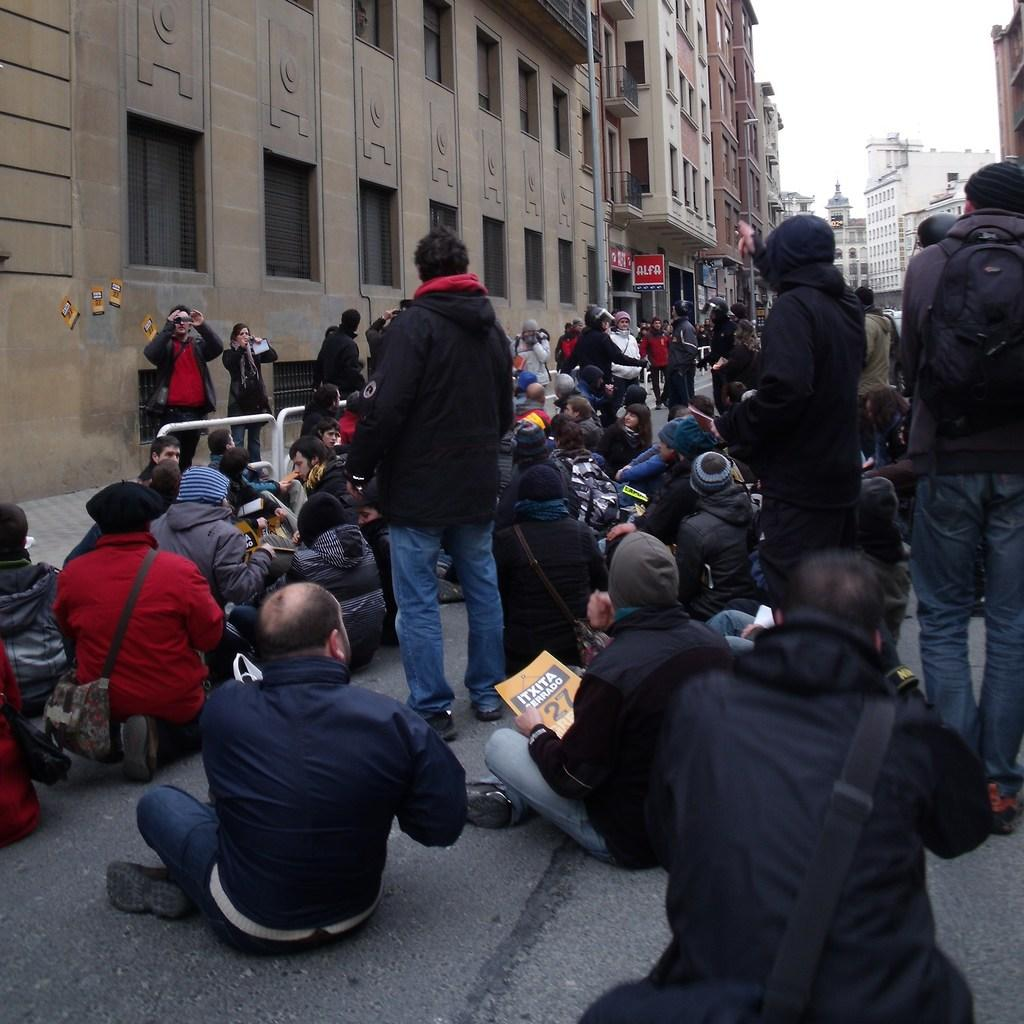What are the people in the image doing? There are people sitting and standing on the road in the image. What can be seen in the background of the image? There are buildings, boards, and poles in the background of the image. What is visible in the sky in the image? The sky is visible in the background of the image. How many babies are being carried by their mothers in the image? There are no babies or mothers present in the image. 